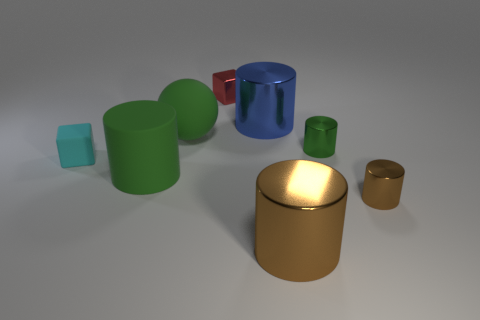How many things are large green matte objects behind the small cyan thing or small brown metal objects?
Offer a terse response. 2. What shape is the object left of the green rubber thing that is on the left side of the rubber object that is behind the matte cube?
Ensure brevity in your answer.  Cube. How many other small rubber things are the same shape as the small brown thing?
Make the answer very short. 0. There is a tiny object that is the same color as the ball; what material is it?
Keep it short and to the point. Metal. Is the material of the tiny red cube the same as the tiny cyan block?
Offer a very short reply. No. What number of big green cylinders are behind the big green rubber thing in front of the matte object that is on the left side of the big rubber cylinder?
Provide a succinct answer. 0. Is there a large green cylinder made of the same material as the tiny brown cylinder?
Offer a very short reply. No. There is a rubber cylinder that is the same color as the big rubber sphere; what size is it?
Provide a succinct answer. Large. Is the number of big yellow matte spheres less than the number of blue things?
Offer a very short reply. Yes. There is a small cube behind the big blue metal object; is its color the same as the tiny rubber cube?
Your answer should be compact. No. 